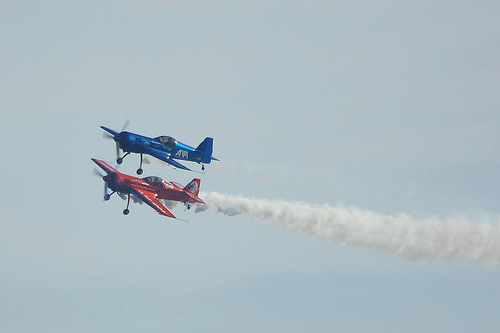Can you tell me the colors of the two airplanes? Certainly! The airplane with the entrails is predominantly red with some white markings, while the other airplane is blue with white and a bit of red detailing. 